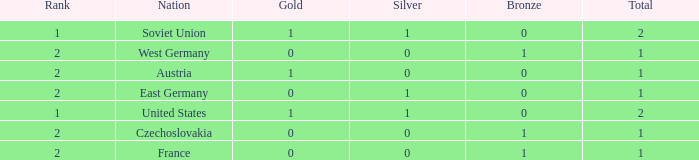What is the highest rank of Austria, which had less than 0 silvers? None. 